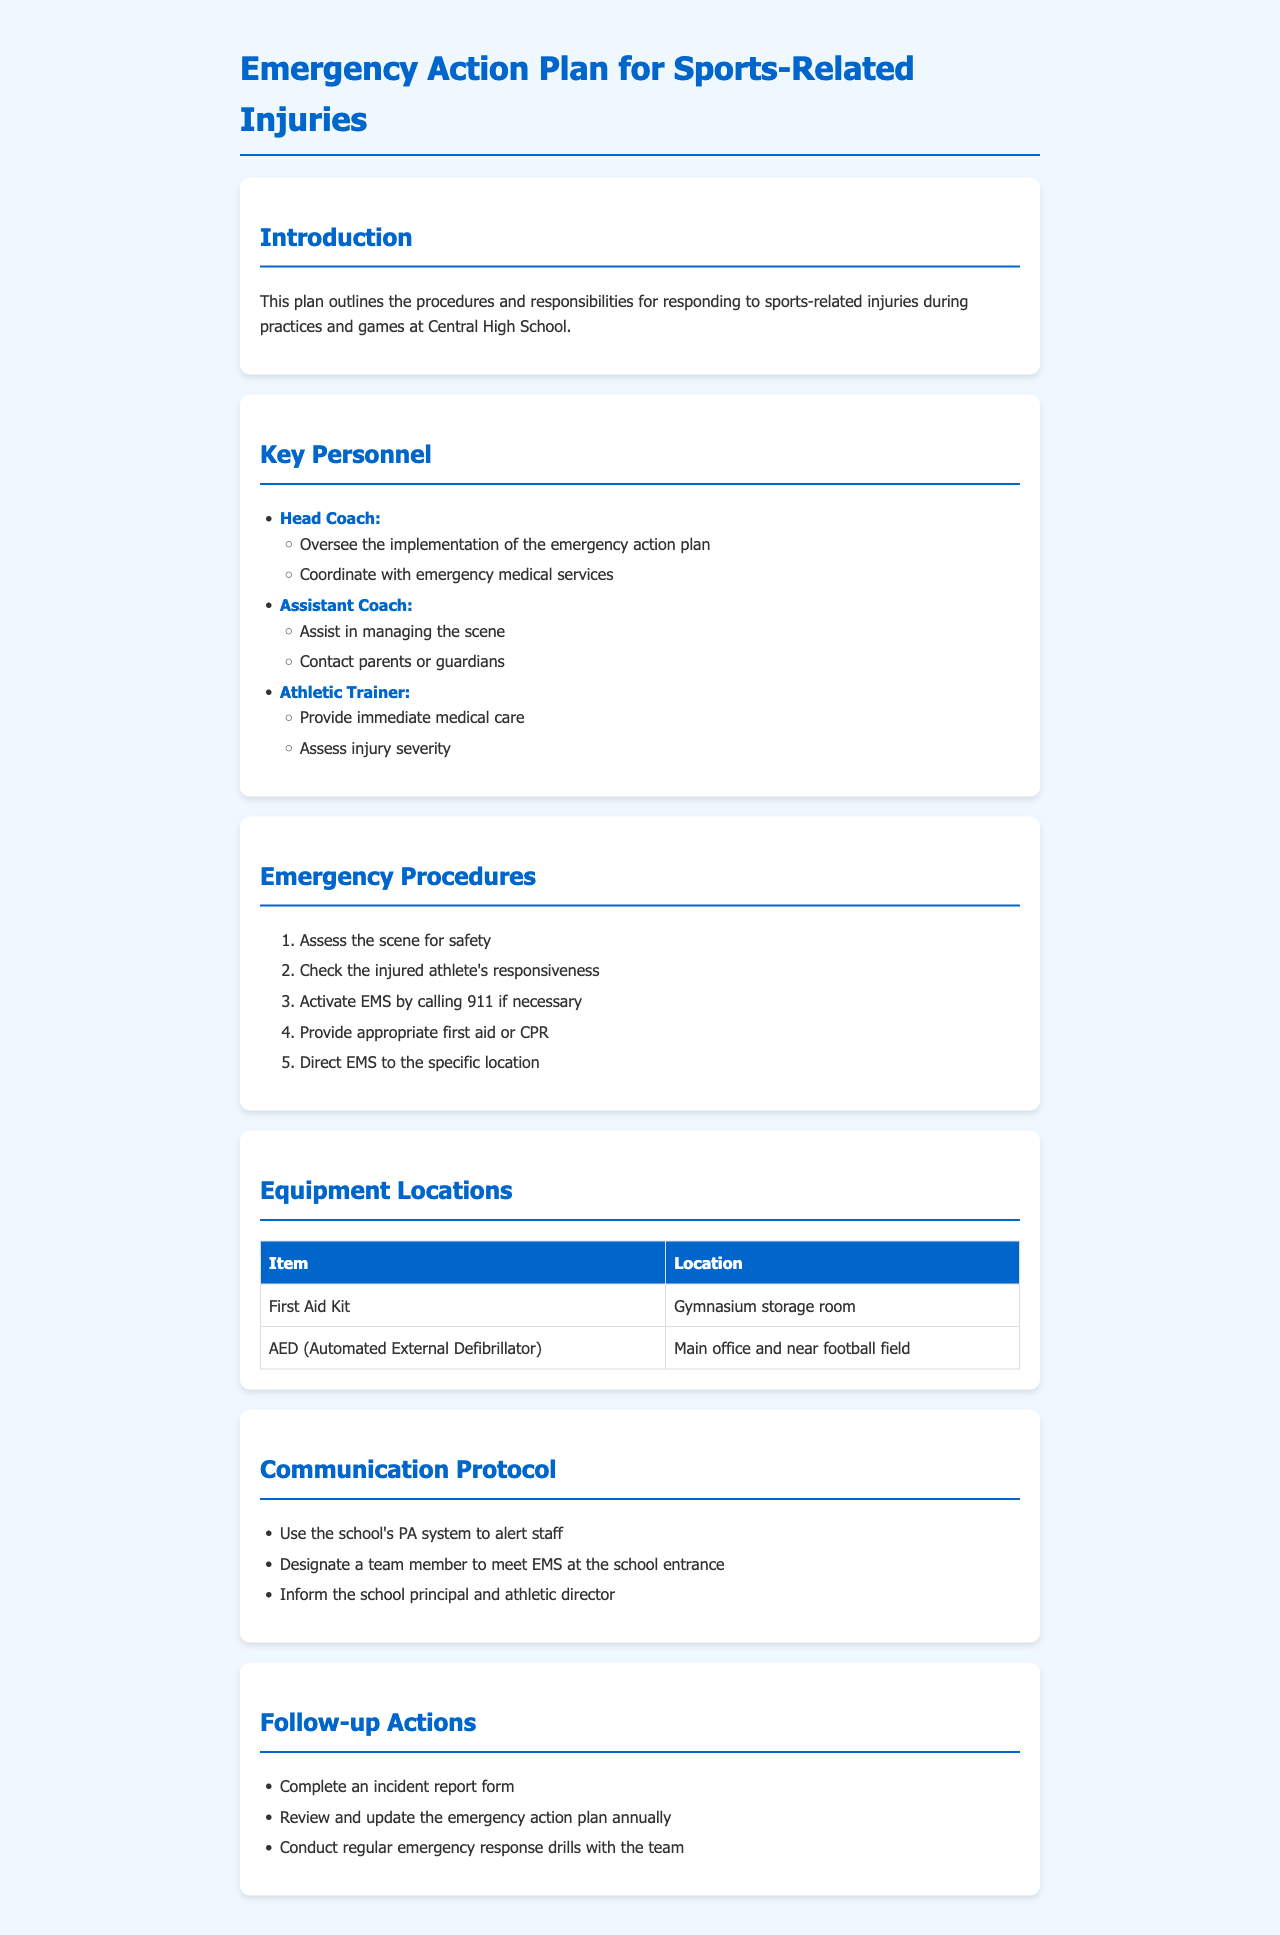What is the title of the document? The title of the document is specified in the header section of the HTML code.
Answer: Emergency Action Plan for Sports-Related Injuries Who coordinates with emergency medical services? This role is described in the "Key Personnel" section, specifically under the Head Coach.
Answer: Head Coach What is the first step in the emergency procedures? The first step is listed in the "Emergency Procedures" section as part of the ordered list.
Answer: Assess the scene for safety Where is the first aid kit located? The location of the first aid kit is found in the "Equipment Locations" table.
Answer: Gymnasium storage room What should be done after an incident? Follow-up actions are outlined in the "Follow-up Actions" section of the document.
Answer: Complete an incident report form Who is responsible for informing the school principal? This responsibility is included in the "Communication Protocol" section regarding communication during an emergency.
Answer: Designated team member 